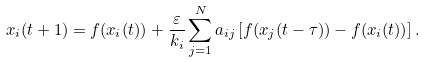Convert formula to latex. <formula><loc_0><loc_0><loc_500><loc_500>x _ { i } ( t + 1 ) = f ( x _ { i } ( t ) ) + \frac { \varepsilon } { k _ { i } } \sum _ { j = 1 } ^ { N } a _ { i j } \left [ f ( x _ { j } ( t - \tau ) ) - f ( x _ { i } ( t ) ) \right ] .</formula> 